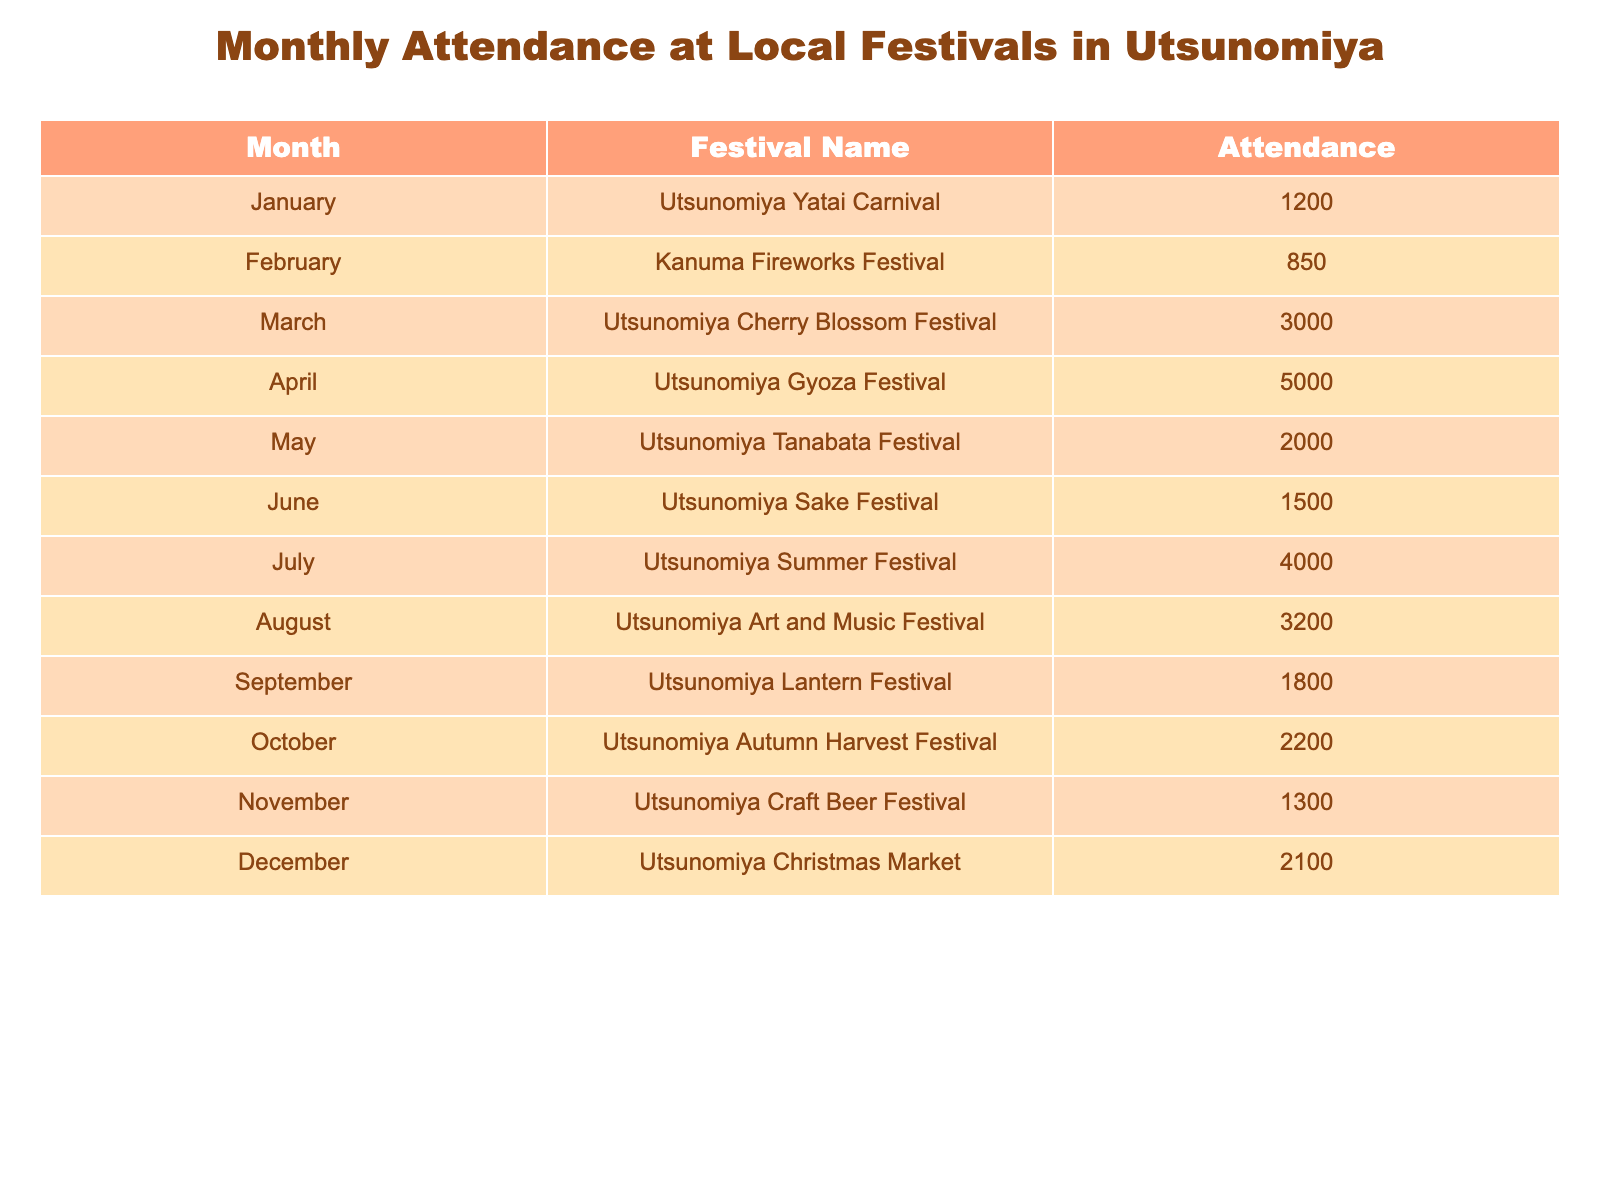What was the attendance for the Utsunomiya Sake Festival in June? The table indicates that the attendance for the Utsunomiya Sake Festival, which is in June, is 1500.
Answer: 1500 Which festival had the highest attendance in the past year? According to the data, the Utsunomiya Gyoza Festival in April had the highest attendance with 5000 attendees.
Answer: Utsunomiya Gyoza Festival What is the total attendance for local festivals from January to March? To find the total attendance from January to March, add the attendance figures for each month: 1200 (January) + 850 (February) + 3000 (March) = 5050.
Answer: 5050 Did the Utsunomiya Summer Festival in July have an attendance greater than 3500? Yes, the Utsunomiya Summer Festival in July had an attendance of 4000, which is indeed greater than 3500.
Answer: Yes What is the average attendance for the festivals held in the second half of the year (July to December)? To calculate the average attendance for these festivals, sum the attendances from July to December (4000 + 3200 + 1800 + 2200 + 1300 + 2100 = 15600) and divide by the number of festivals (6): 15600 / 6 = 2600.
Answer: 2600 Which month had lower attendance, August or September? The attendance for August (3200) is higher than September (1800), so September had lower attendance.
Answer: September What was the difference in attendance between the Utsunomiya Tanabata Festival in May and the Utsunomiya Lantern Festival in September? The attendance for the Tanabata Festival is 2000 and for the Lantern Festival is 1800. The difference is 2000 - 1800 = 200.
Answer: 200 Was the attendance for the Kanuma Fireworks Festival in February above 900? No, the attendance for the Kanuma Fireworks Festival was 850, which is below 900.
Answer: No What was the combined attendance of the Utsunomiya Craft Beer Festival and the Utsunomiya Christmas Market in November and December? To find the combined attendance, add the two figures: 1300 (Craft Beer Festival) + 2100 (Christmas Market) = 3400.
Answer: 3400 